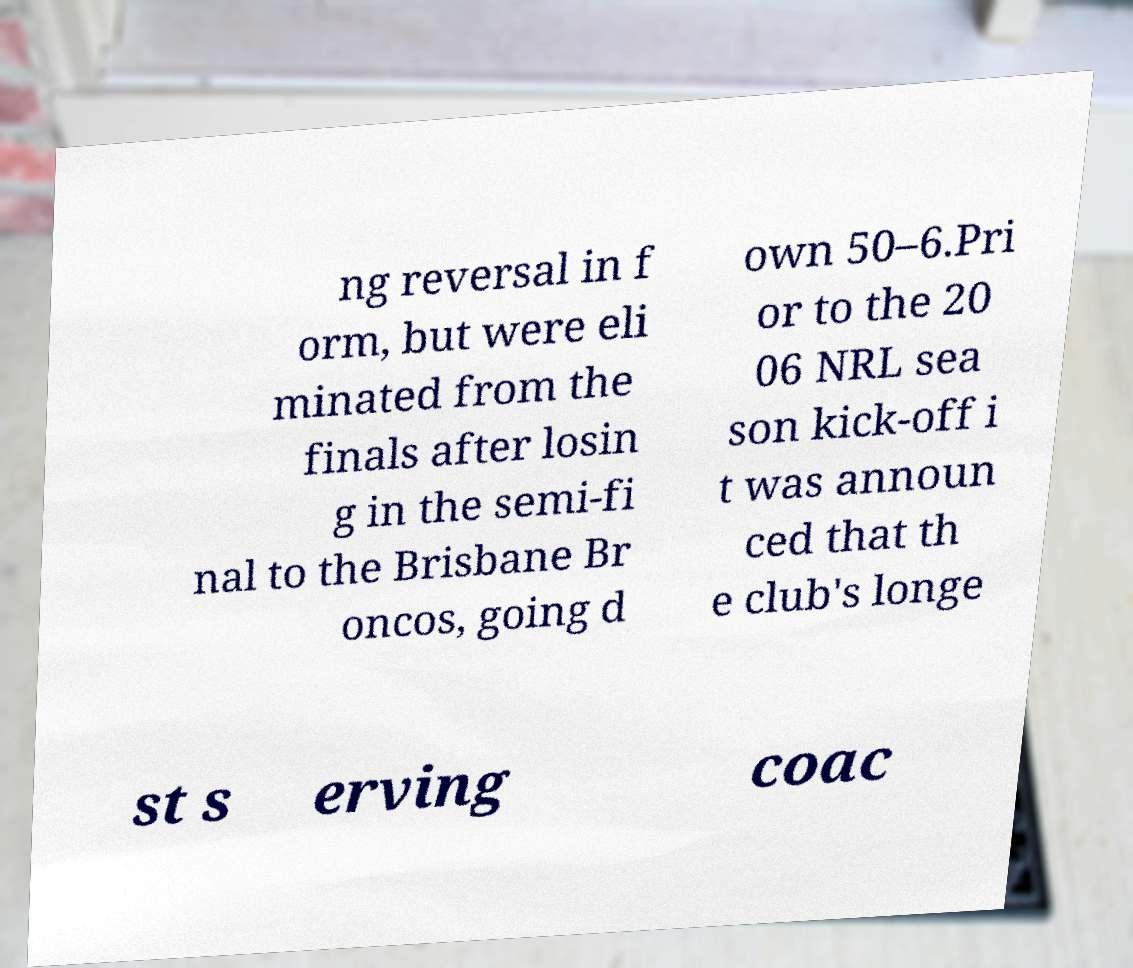I need the written content from this picture converted into text. Can you do that? ng reversal in f orm, but were eli minated from the finals after losin g in the semi-fi nal to the Brisbane Br oncos, going d own 50–6.Pri or to the 20 06 NRL sea son kick-off i t was announ ced that th e club's longe st s erving coac 